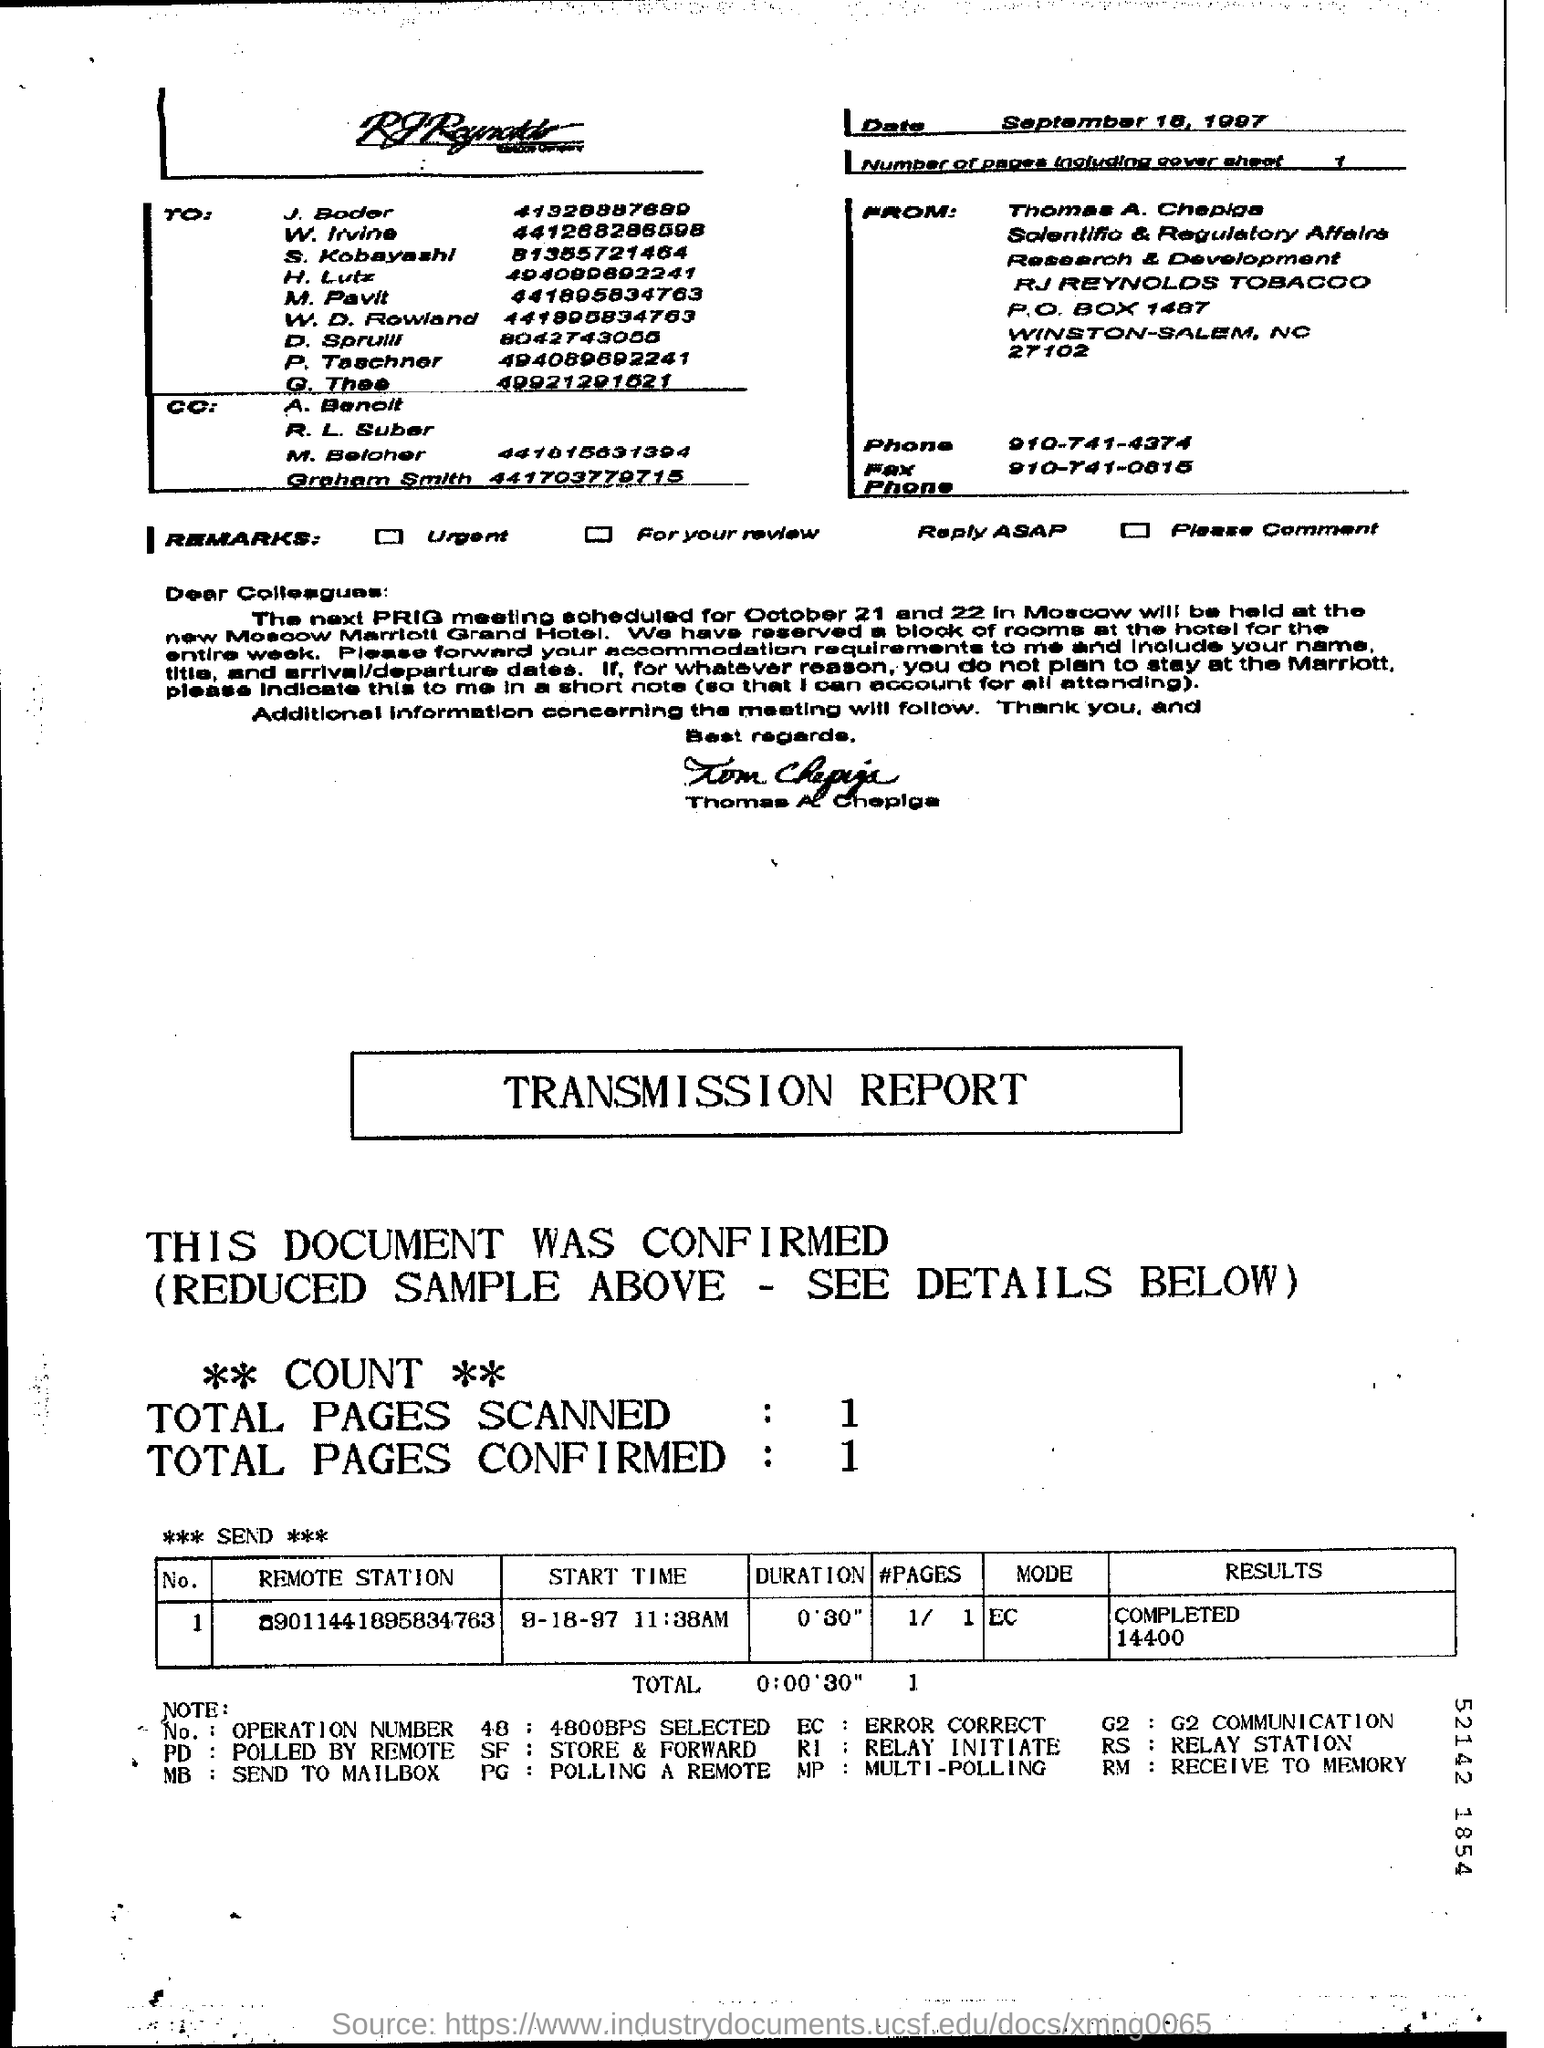Outline some significant characteristics in this image. The mode in the transmission report is EC. The phone number for Thomas A. Chepiga is 910-741-0815. The duration reported in the transmission is 0:00'30. The phone number of Thomas A. Chepiga is 910-741-4374. The number of pages in the fax, including the cover sheet, is one. 